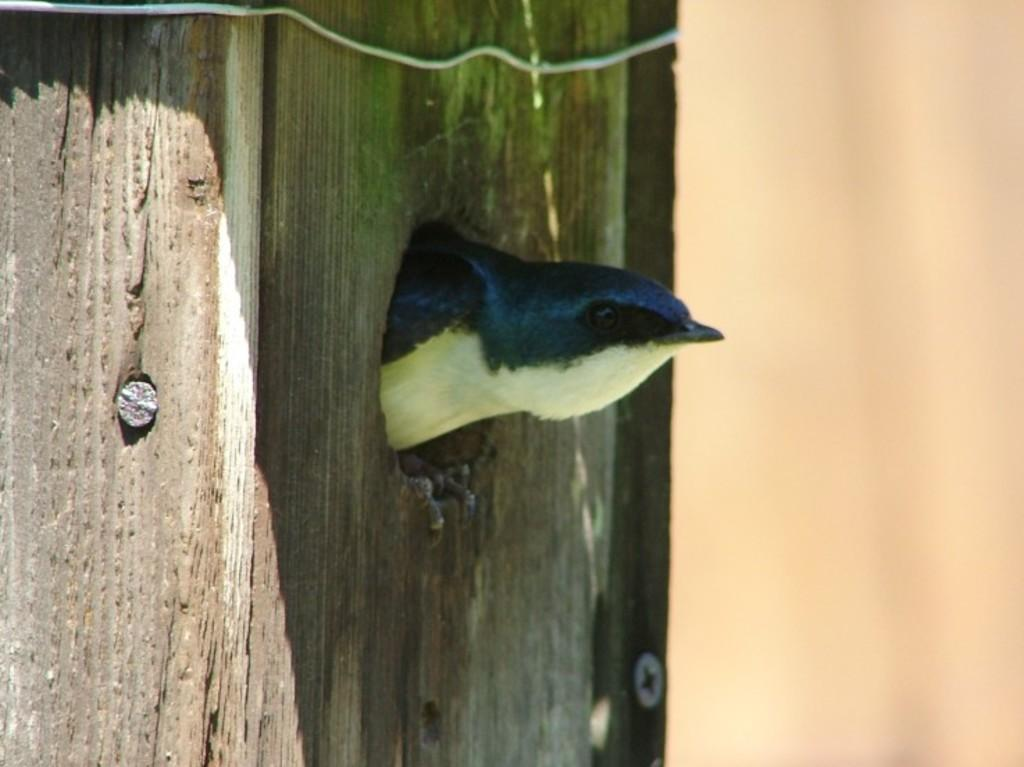What type of animal can be seen in the image? There is a bird in the image. What are the small, metallic objects in the image? There are screws in the image. What material is the wooden object made of? The wooden object is made of wood. How would you describe the background of the image? The background of the image is blurry. What type of cloth is the bird using to fly in the image? There is no cloth present in the image, and the bird is not using any cloth to fly. 